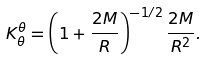<formula> <loc_0><loc_0><loc_500><loc_500>K ^ { \theta } _ { \theta } = \left ( 1 + \frac { 2 M } { R } \right ) ^ { - 1 / 2 } \frac { 2 M } { R ^ { 2 } } .</formula> 